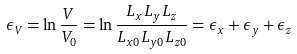<formula> <loc_0><loc_0><loc_500><loc_500>\epsilon _ { V } = \ln \frac { V } { V _ { 0 } } = \ln \frac { L _ { x } L _ { y } L _ { z } } { L _ { x 0 } L _ { y 0 } L _ { z 0 } } = \epsilon _ { x } + \epsilon _ { y } + \epsilon _ { z }</formula> 